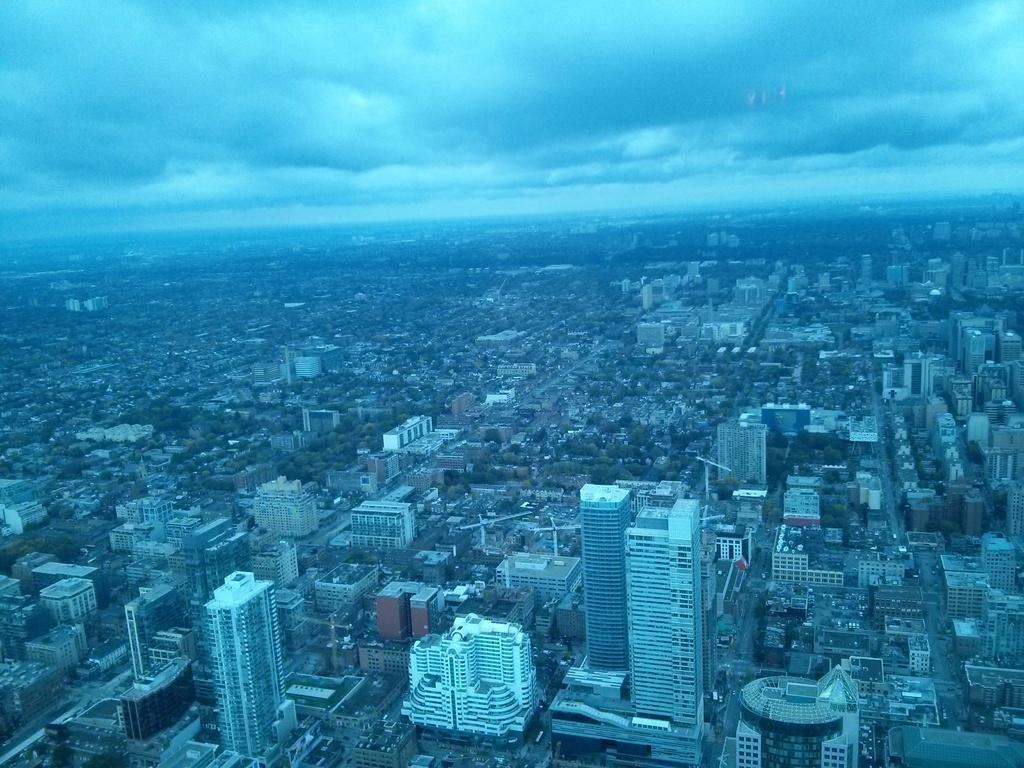Can you describe this image briefly? In this image, I can see the view of the city. These are the skyscrapers and the buildings. I can see the trees. These are the clouds in the sky. 